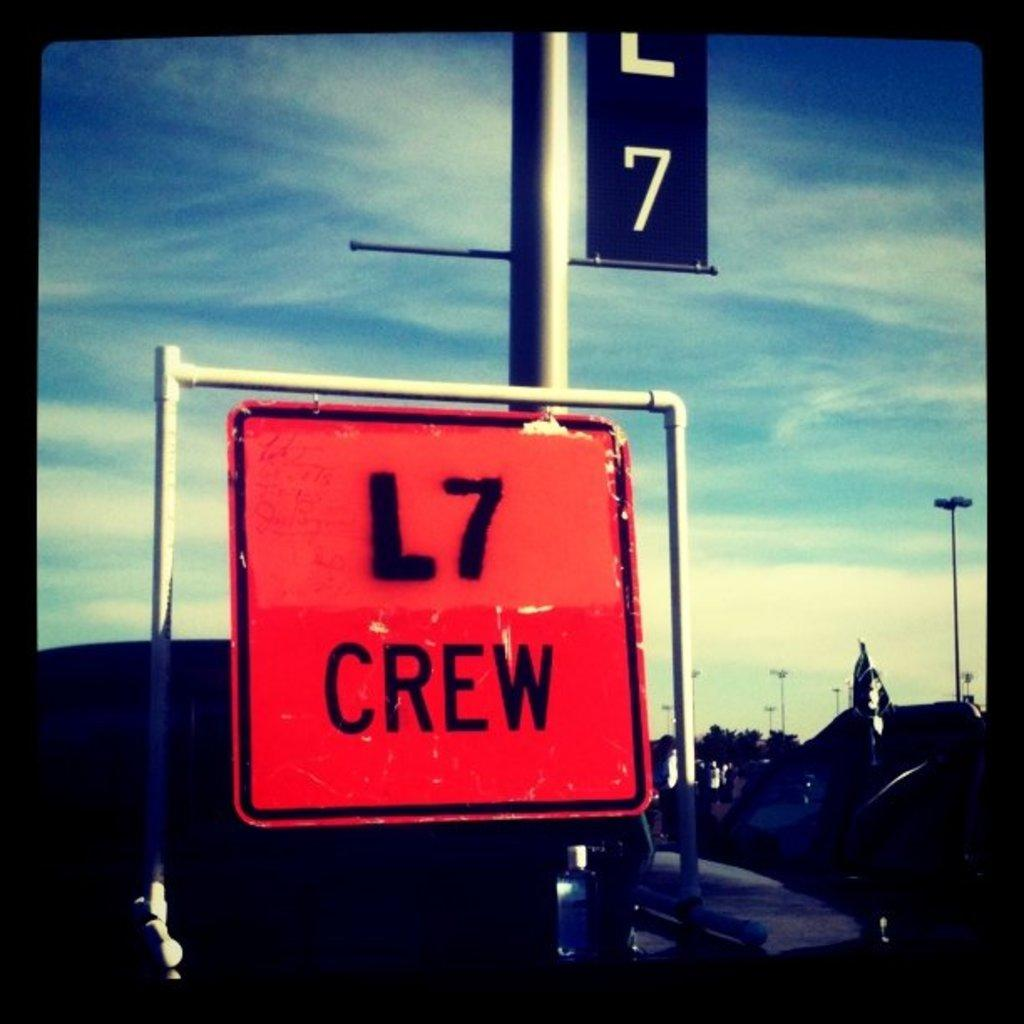<image>
Offer a succinct explanation of the picture presented. A sign in red which has the word Crew on it in black. 